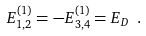Convert formula to latex. <formula><loc_0><loc_0><loc_500><loc_500>E _ { 1 , 2 } ^ { ( 1 ) } = - E _ { 3 , 4 } ^ { ( 1 ) } = E _ { D } \ .</formula> 